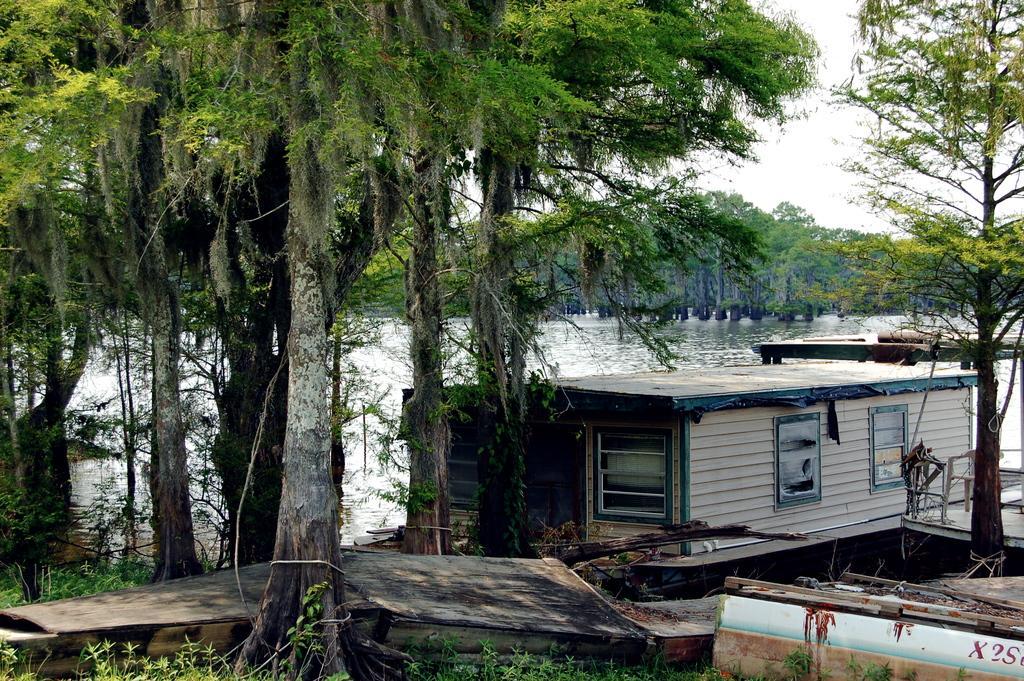Describe this image in one or two sentences. In the picture I can see a boat on the water. I can also see trees, the grass and some other objects. In the background I can see the sky. 